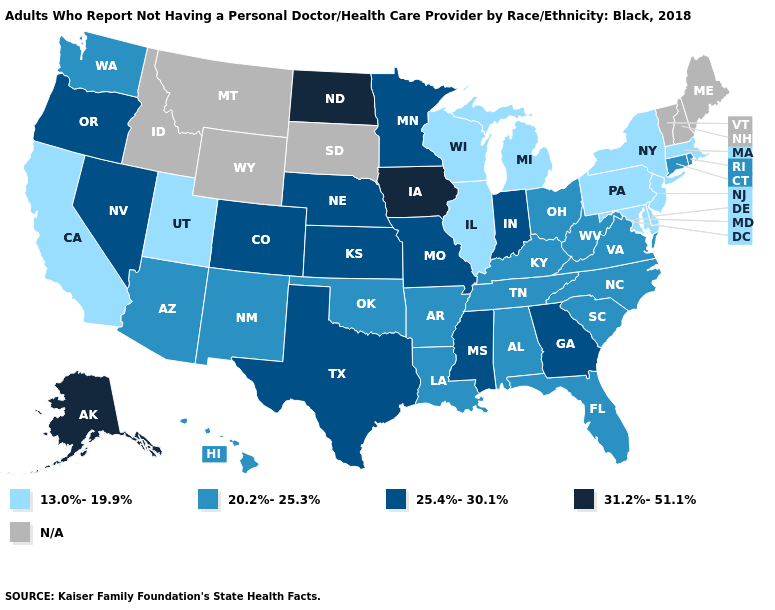Is the legend a continuous bar?
Answer briefly. No. Name the states that have a value in the range N/A?
Quick response, please. Idaho, Maine, Montana, New Hampshire, South Dakota, Vermont, Wyoming. Name the states that have a value in the range 31.2%-51.1%?
Be succinct. Alaska, Iowa, North Dakota. What is the highest value in the USA?
Answer briefly. 31.2%-51.1%. Name the states that have a value in the range 20.2%-25.3%?
Concise answer only. Alabama, Arizona, Arkansas, Connecticut, Florida, Hawaii, Kentucky, Louisiana, New Mexico, North Carolina, Ohio, Oklahoma, Rhode Island, South Carolina, Tennessee, Virginia, Washington, West Virginia. Which states have the lowest value in the MidWest?
Answer briefly. Illinois, Michigan, Wisconsin. Does Indiana have the highest value in the MidWest?
Be succinct. No. Does Rhode Island have the highest value in the Northeast?
Answer briefly. Yes. Name the states that have a value in the range 25.4%-30.1%?
Quick response, please. Colorado, Georgia, Indiana, Kansas, Minnesota, Mississippi, Missouri, Nebraska, Nevada, Oregon, Texas. What is the value of South Dakota?
Answer briefly. N/A. What is the value of South Dakota?
Quick response, please. N/A. What is the lowest value in states that border Kansas?
Keep it brief. 20.2%-25.3%. What is the value of Illinois?
Keep it brief. 13.0%-19.9%. Does the first symbol in the legend represent the smallest category?
Write a very short answer. Yes. 